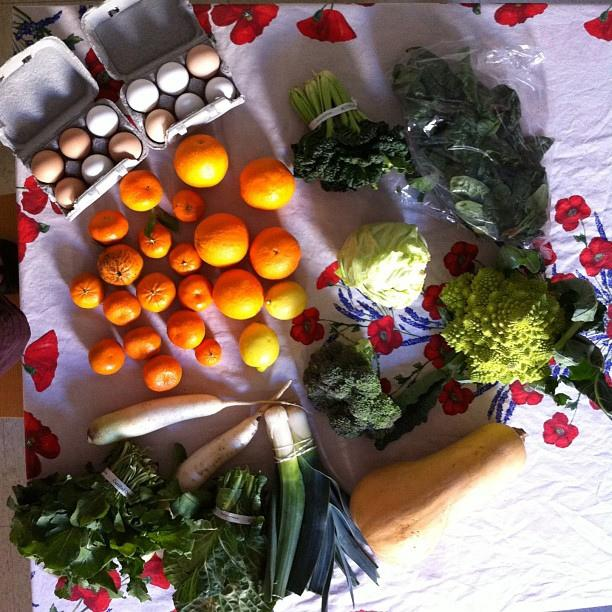Why are the eggs placed in the container? Please explain your reasoning. protection. Eggs are very fragile and can easily crack, so the container cradles them and keeps them protected until someone wishes to crack them for cooking. 